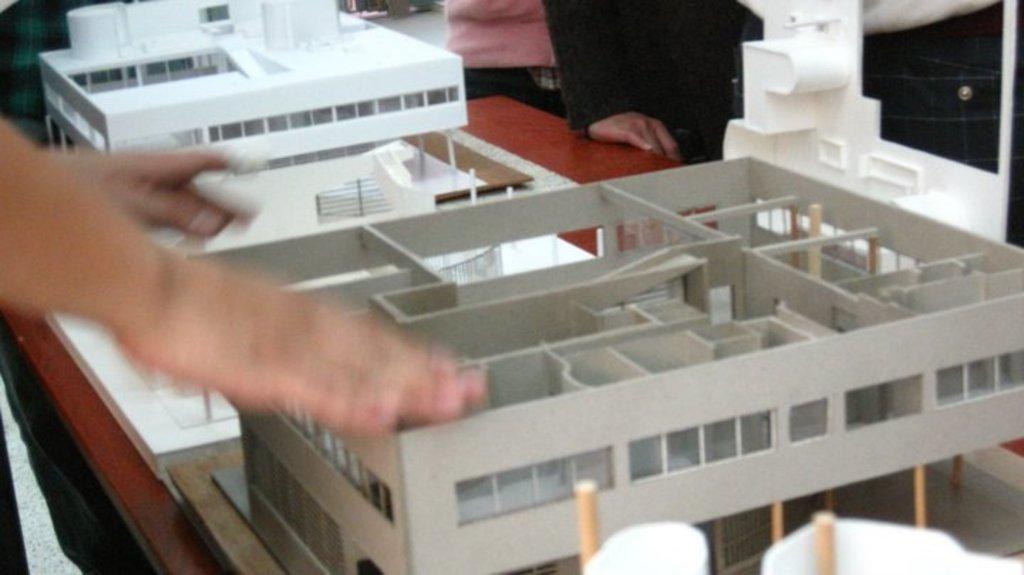How would you summarize this image in a sentence or two? In this image, we can see persons in front of the table. This table contains building models. 